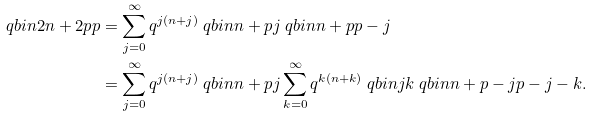<formula> <loc_0><loc_0><loc_500><loc_500>\ q b i n { 2 n + 2 p } { p } & = \sum _ { j = 0 } ^ { \infty } q ^ { j ( n + j ) } \ q b i n { n + p } { j } \ q b i n { n + p } { p - j } \\ & = \sum _ { j = 0 } ^ { \infty } q ^ { j ( n + j ) } \ q b i n { n + p } { j } \sum _ { k = 0 } ^ { \infty } q ^ { k ( n + k ) } \ q b i n { j } { k } \ q b i n { n + p - j } { p - j - k } .</formula> 